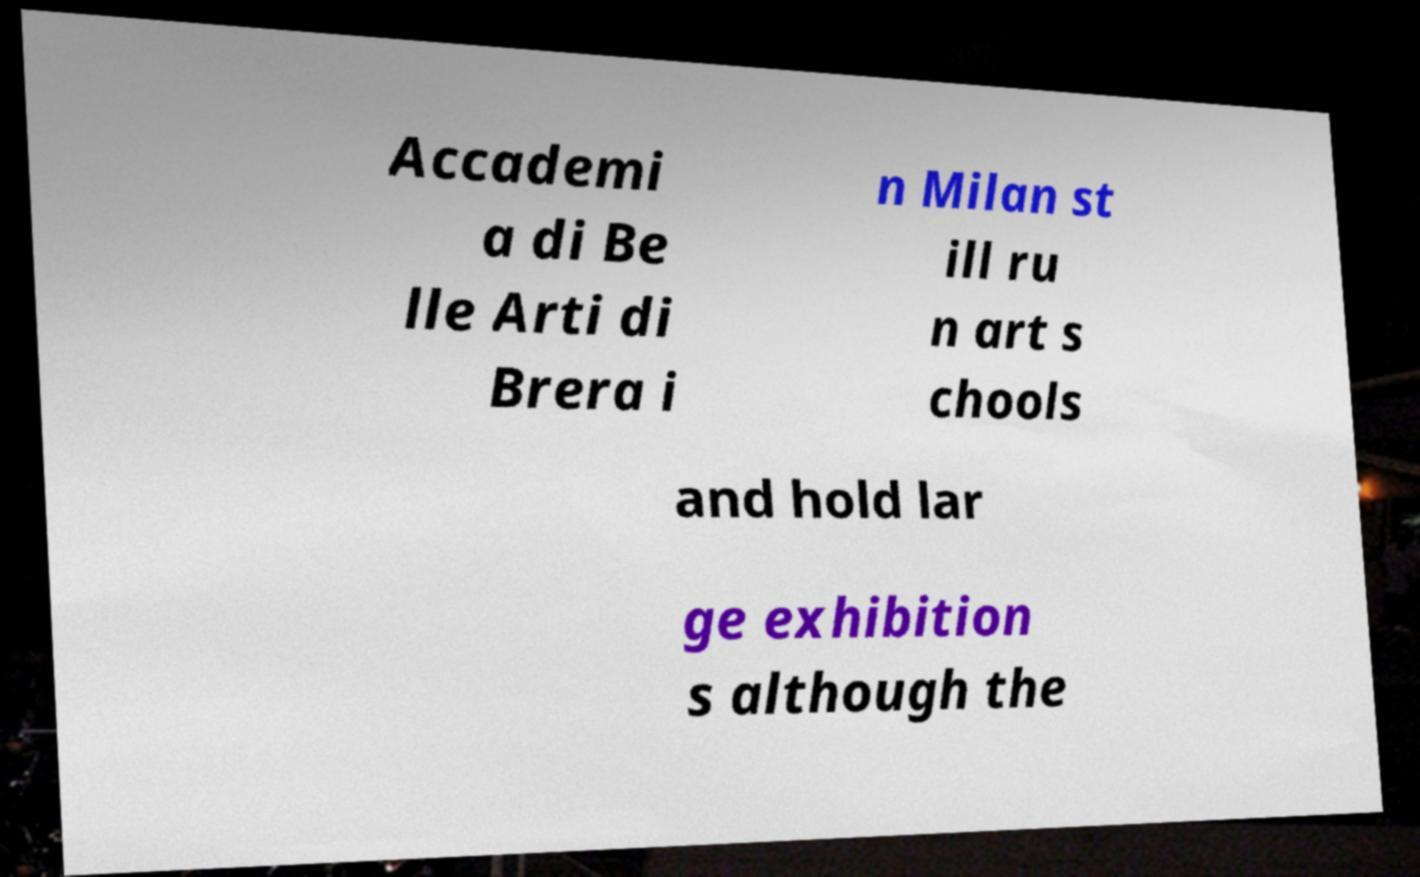I need the written content from this picture converted into text. Can you do that? Accademi a di Be lle Arti di Brera i n Milan st ill ru n art s chools and hold lar ge exhibition s although the 